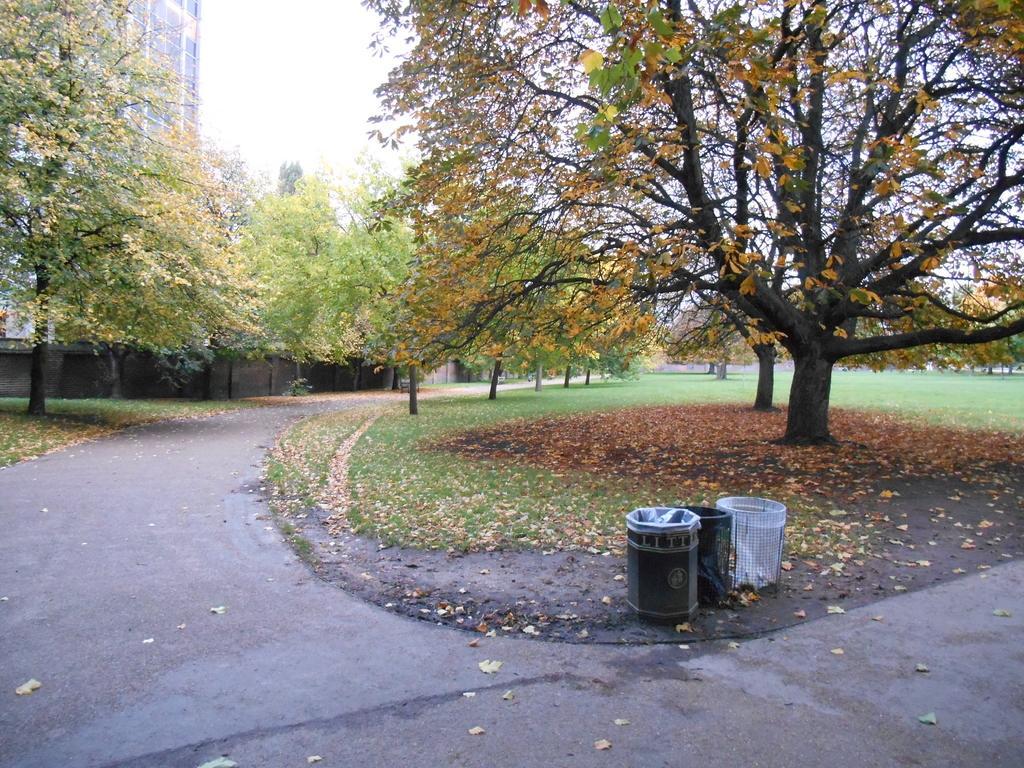In one or two sentences, can you explain what this image depicts? In the image we can see there are trees and the building. Here we can see the road, dry leaves, grass and the sky. 